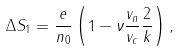Convert formula to latex. <formula><loc_0><loc_0><loc_500><loc_500>\Delta S _ { 1 } = \frac { e } { n _ { 0 } } \left ( 1 - \nu \frac { v _ { n } } { v _ { c } } \frac { 2 } { k } \right ) ,</formula> 